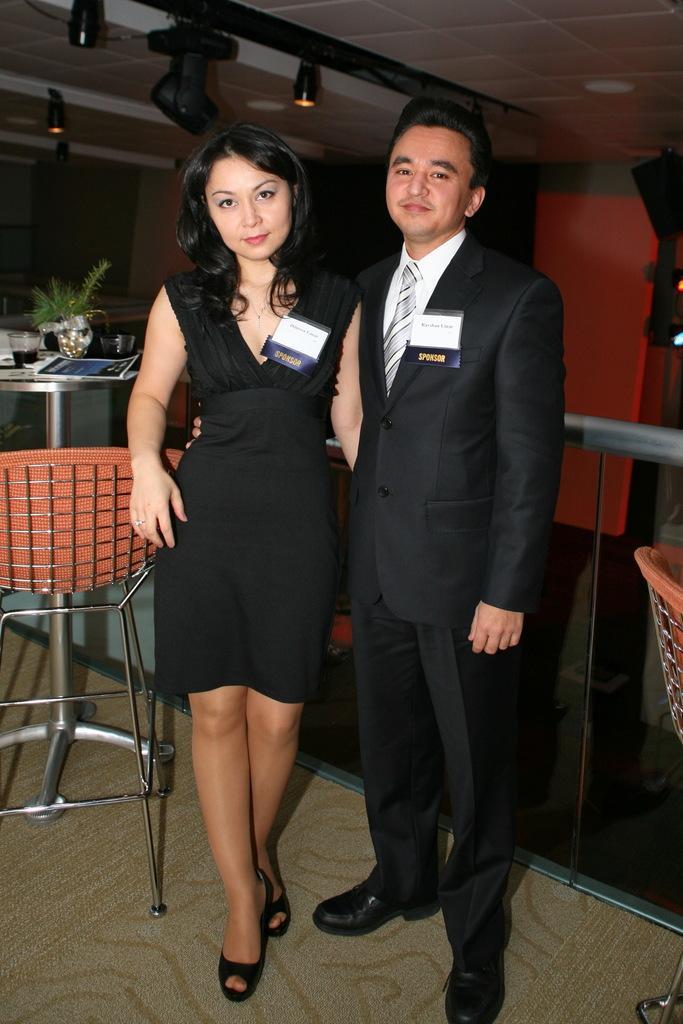In one or two sentences, can you explain what this image depicts? In this image we can see a man and a woman are standing and posing for a photo and on the left side of the image we can see a chair and a table with some objects and there are some lights attached to the ceiling. 